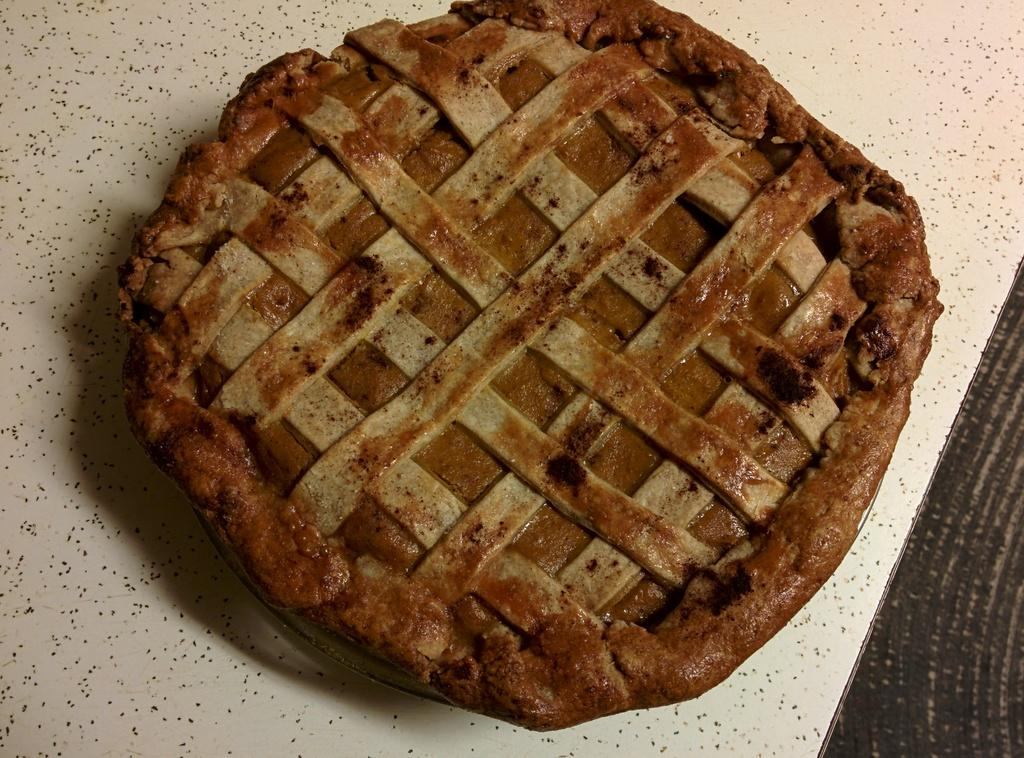What is the main subject of the image? The main subject of the image is a pie crust. Where is the pie crust located in the image? The pie crust is in the center of the image. On what surface is the pie crust placed? The pie crust is placed on a table. What religious symbol can be seen in the image? A: There is no religious symbol present in the image; it features a pie crust placed on a table. What type of harbor is visible in the image? There is no harbor present in the image; it features a pie crust placed on a table. 